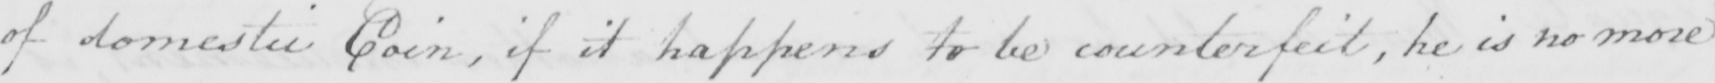Can you read and transcribe this handwriting? of domestic Coin , if it happens to be counterfeit , he is no more 